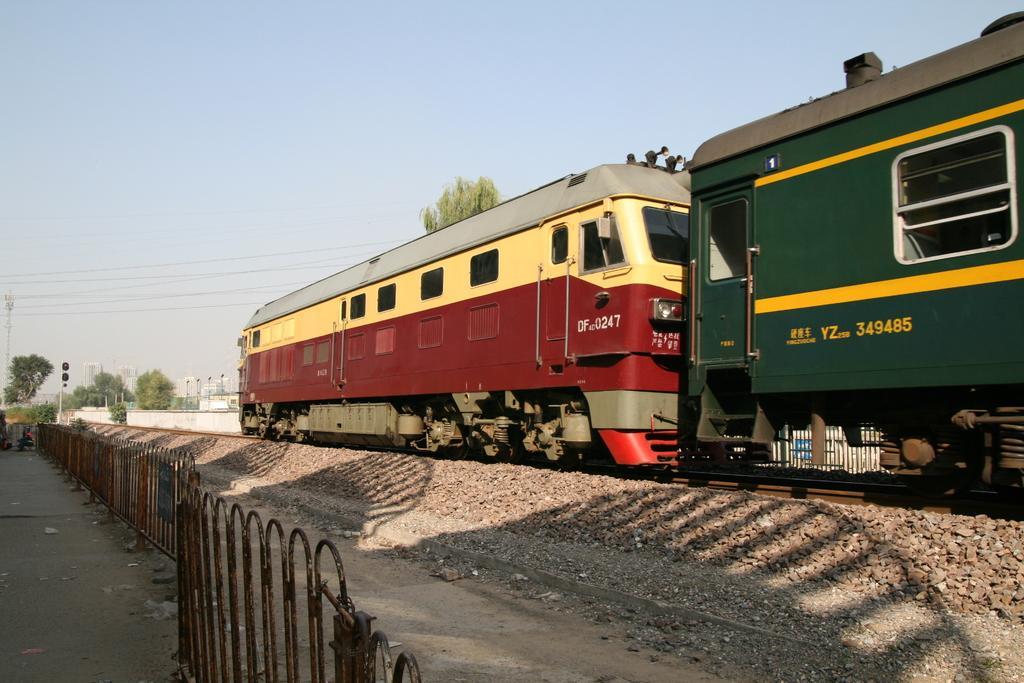Could you give a brief overview of what you see in this image? There is a train on a railway track as we can see in the middle of this image, and there is a fence in the bottom left corner of this image. We can see a sky at the top of this image, and trees on the left side of this image. 